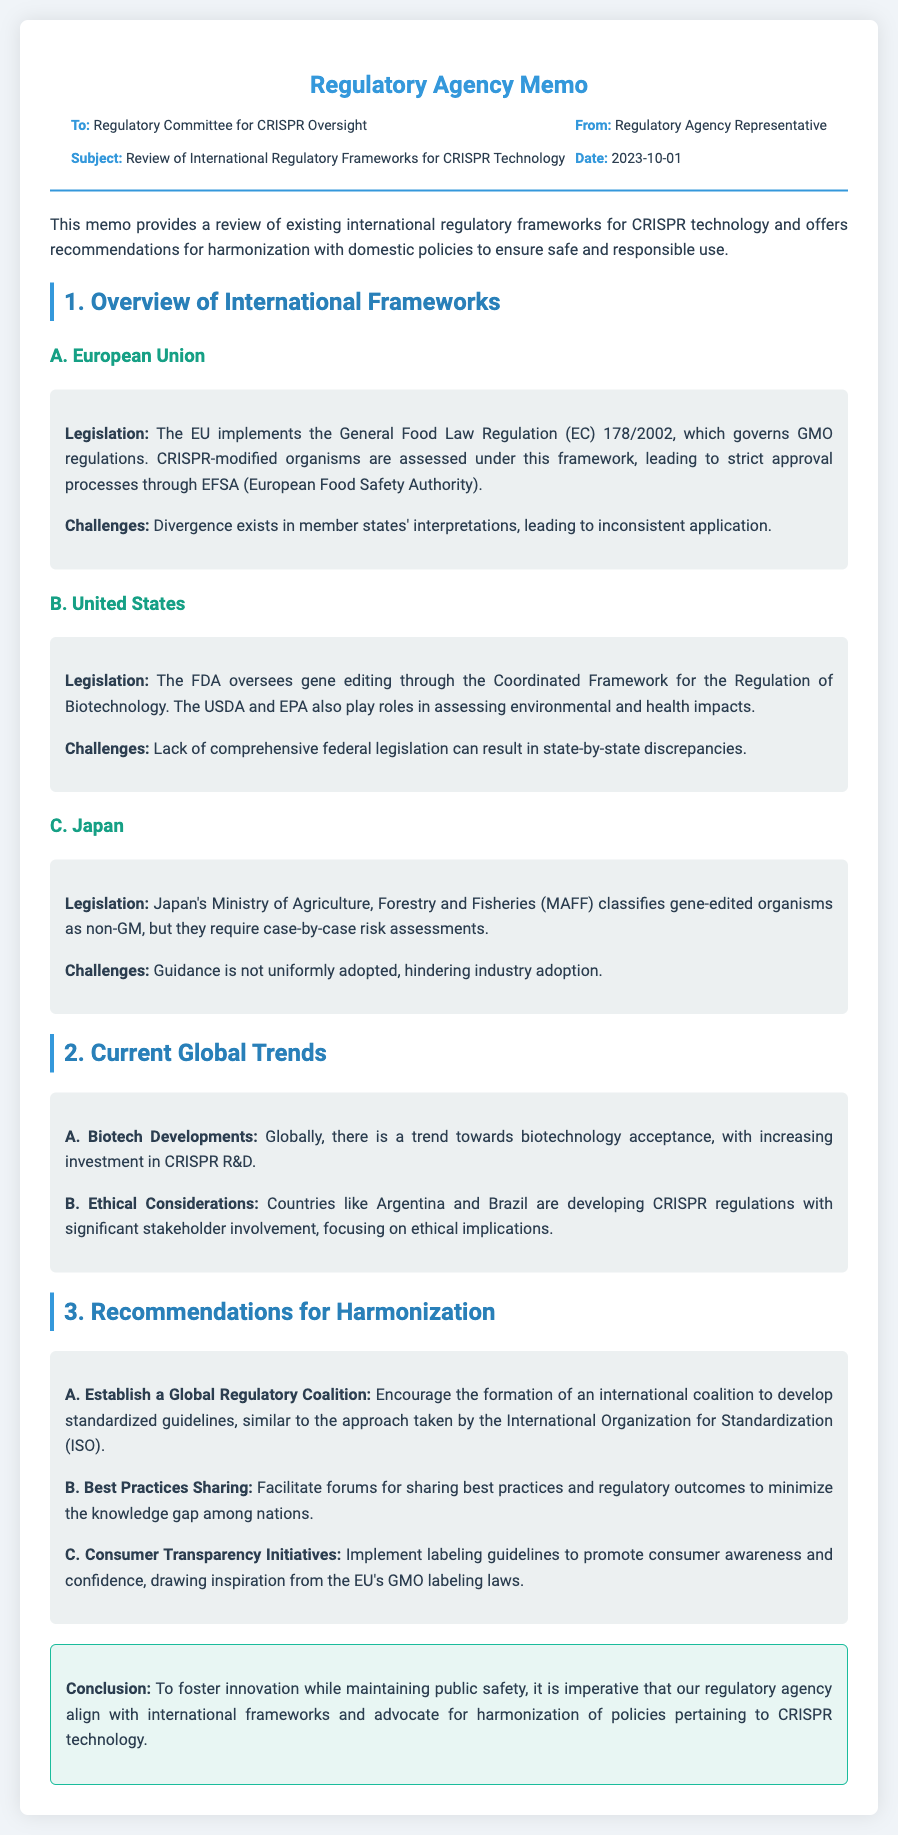What is the date of the memo? The date of the memo is mentioned in the meta section, specifically under "Date."
Answer: 2023-10-01 Who oversees gene editing in the United States? The document indicates that the FDA oversees gene editing through a specific regulatory framework.
Answer: FDA What is the main legislation governing the EU's CRISPR regulations? The memo describes the General Food Law Regulation (EC) 178/2002 as the main legislation governing GMO regulations in the EU.
Answer: General Food Law Regulation (EC) 178/2002 What country classifies gene-edited organisms as non-GM? The memo states that Japan's Ministry of Agriculture classifies gene-edited organisms as non-GM.
Answer: Japan What recommendation suggests forming an international coalition? The memo mentions the establishment of a global regulatory coalition as one of the recommendations for harmonization.
Answer: Establish a Global Regulatory Coalition What challenge does Japan face regarding CRISPR regulations? The document points out that guidance is not uniformly adopted in Japan, hindering industry adoption.
Answer: Guidance not uniformly adopted What is a global trend mentioned in the memo? The memo highlights a trend towards biotechnology acceptance and increasing investment in CRISPR R&D.
Answer: Biotechnology acceptance What is the focus of the regulations being developed in Argentina and Brazil? The document states that these countries are focusing on ethical implications in their CRISPR regulations.
Answer: Ethical implications 